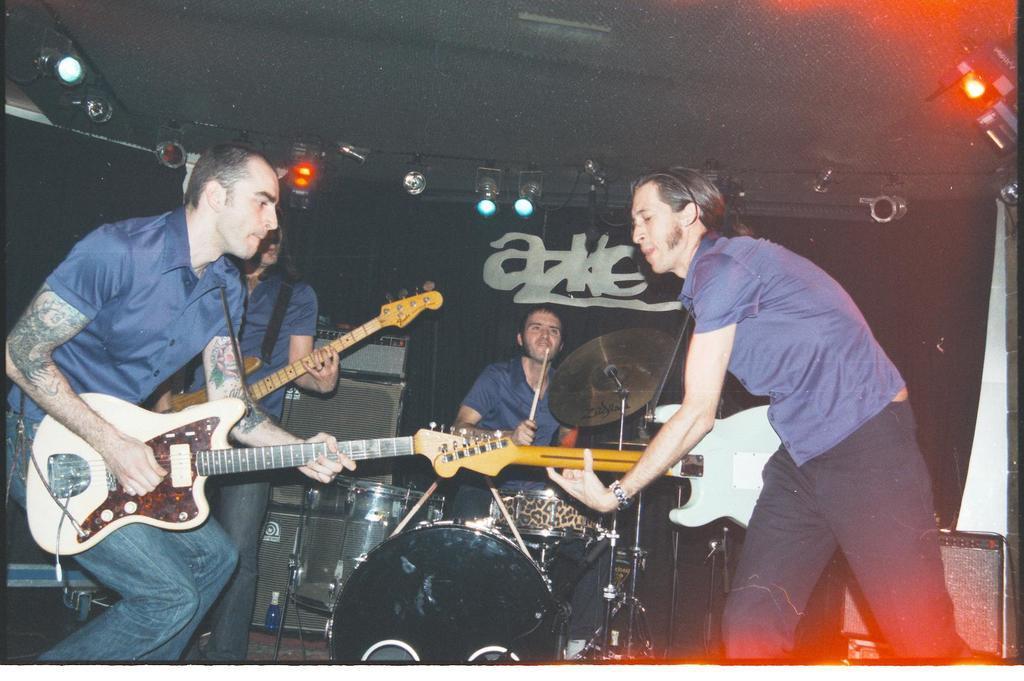In one or two sentences, can you explain what this image depicts? In the picture we can see four people, two people are holding a guitar, just behind them one person is holding a guitar and one is playing the drums. In the background we can find the lights, music boxes. 